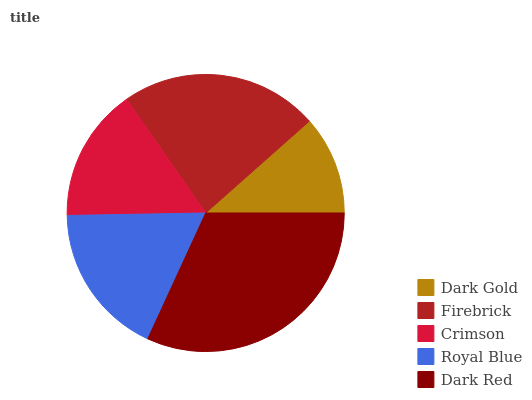Is Dark Gold the minimum?
Answer yes or no. Yes. Is Dark Red the maximum?
Answer yes or no. Yes. Is Firebrick the minimum?
Answer yes or no. No. Is Firebrick the maximum?
Answer yes or no. No. Is Firebrick greater than Dark Gold?
Answer yes or no. Yes. Is Dark Gold less than Firebrick?
Answer yes or no. Yes. Is Dark Gold greater than Firebrick?
Answer yes or no. No. Is Firebrick less than Dark Gold?
Answer yes or no. No. Is Royal Blue the high median?
Answer yes or no. Yes. Is Royal Blue the low median?
Answer yes or no. Yes. Is Crimson the high median?
Answer yes or no. No. Is Crimson the low median?
Answer yes or no. No. 